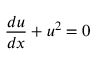<formula> <loc_0><loc_0><loc_500><loc_500>{ \frac { d u } { d x } } + u ^ { 2 } = 0</formula> 